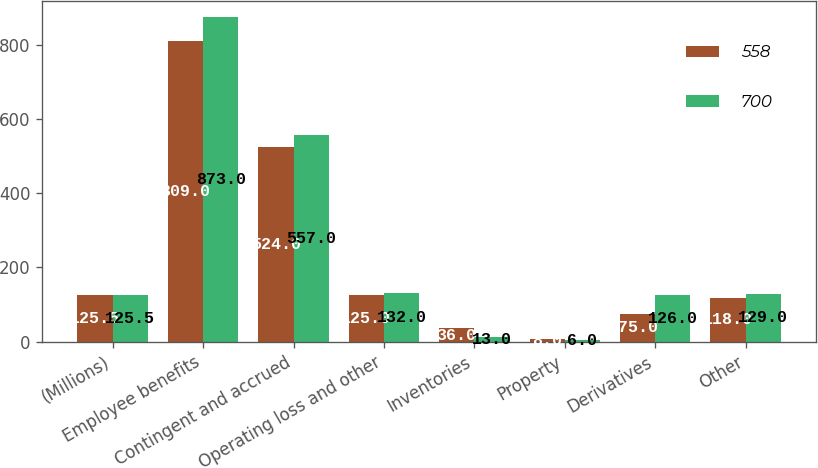Convert chart. <chart><loc_0><loc_0><loc_500><loc_500><stacked_bar_chart><ecel><fcel>(Millions)<fcel>Employee benefits<fcel>Contingent and accrued<fcel>Operating loss and other<fcel>Inventories<fcel>Property<fcel>Derivatives<fcel>Other<nl><fcel>558<fcel>125.5<fcel>809<fcel>524<fcel>125<fcel>36<fcel>8<fcel>75<fcel>118<nl><fcel>700<fcel>125.5<fcel>873<fcel>557<fcel>132<fcel>13<fcel>6<fcel>126<fcel>129<nl></chart> 